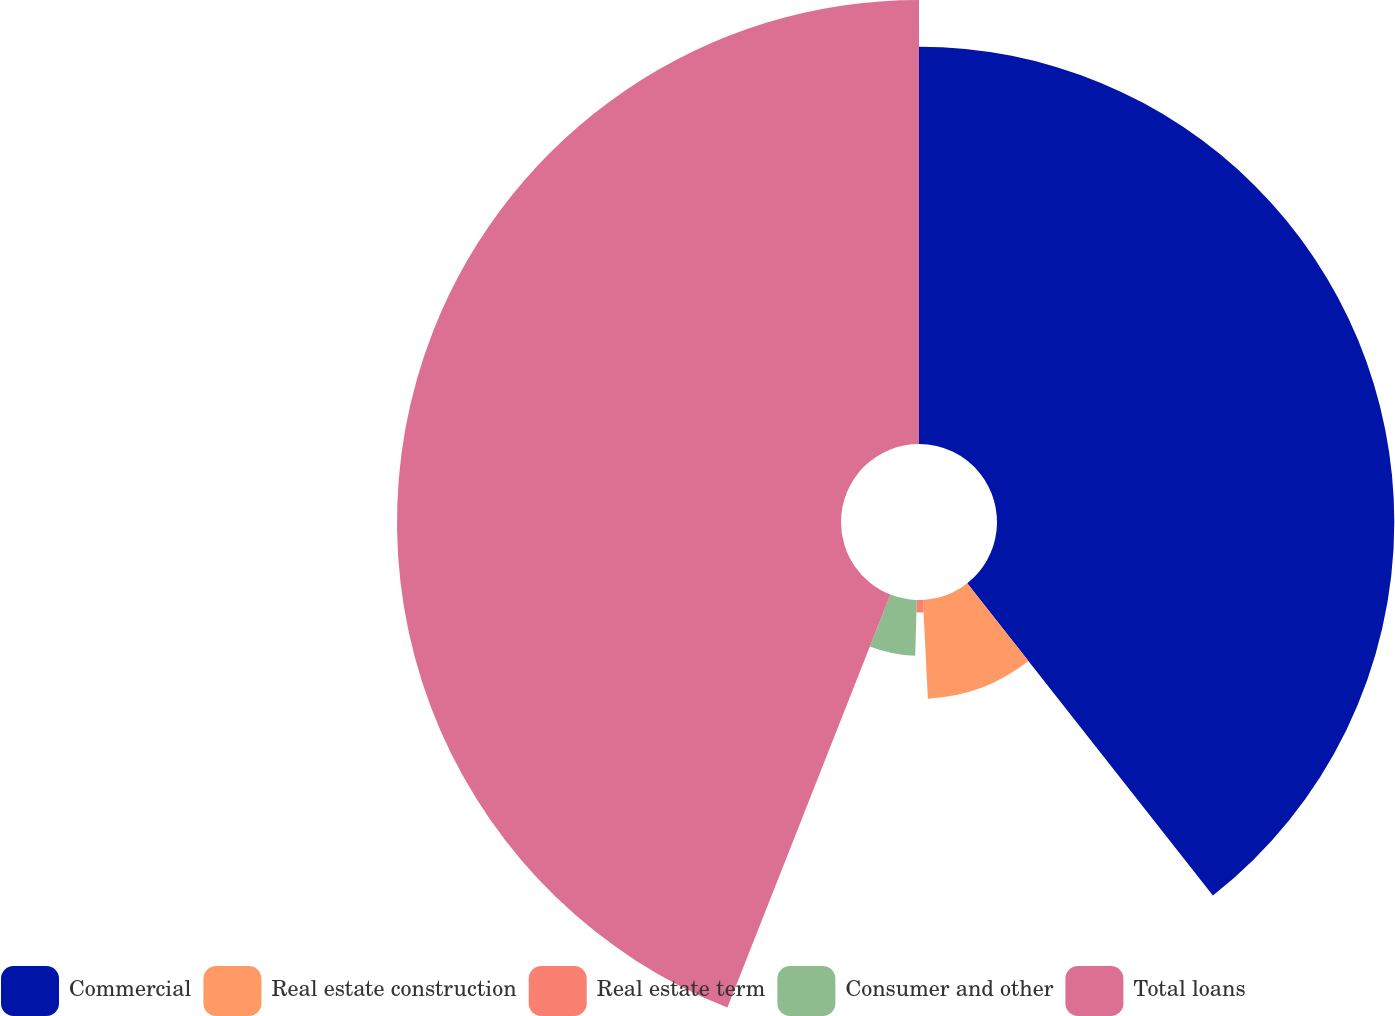Convert chart to OTSL. <chart><loc_0><loc_0><loc_500><loc_500><pie_chart><fcel>Commercial<fcel>Real estate construction<fcel>Real estate term<fcel>Consumer and other<fcel>Total loans<nl><fcel>39.39%<fcel>9.81%<fcel>1.25%<fcel>5.53%<fcel>44.02%<nl></chart> 